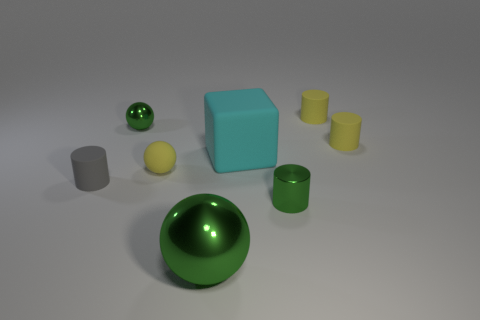In this arrangement, which object stands out the most and why? The large green sphere stands out the most due to its central position, vibrant color, and high reflectivity, which draw the eye amidst the more muted colors and less reflective surfaces of the other objects. Does the composition have any particular aesthetic or practical significance? Aesthetically, the composition uses color contrasts and varied reflectivity to create visual interest, guiding the viewer's eye through the scene. Practically, it may serve as a demonstration of lighting, shading, and material properties in a 3D modeling or visualization context. 